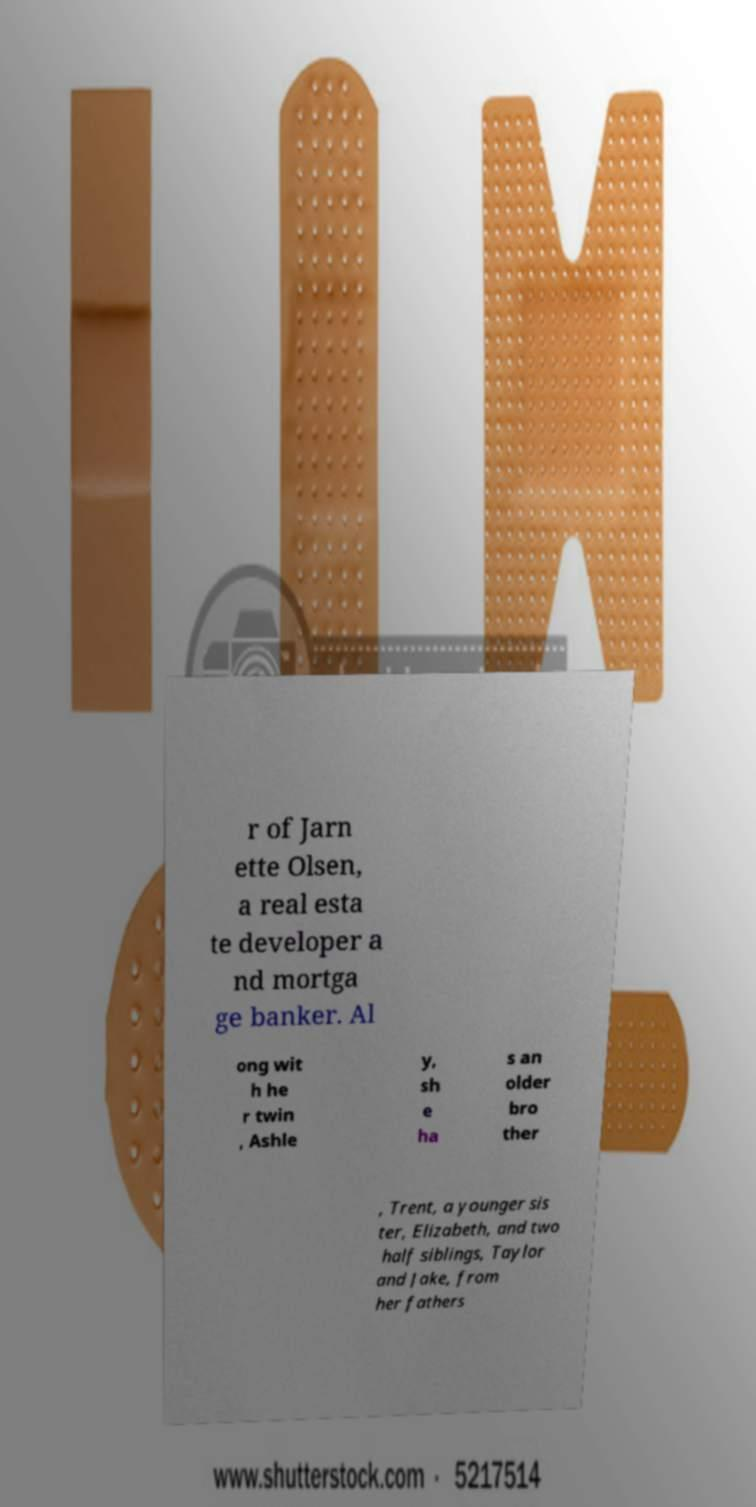What messages or text are displayed in this image? I need them in a readable, typed format. r of Jarn ette Olsen, a real esta te developer a nd mortga ge banker. Al ong wit h he r twin , Ashle y, sh e ha s an older bro ther , Trent, a younger sis ter, Elizabeth, and two half siblings, Taylor and Jake, from her fathers 